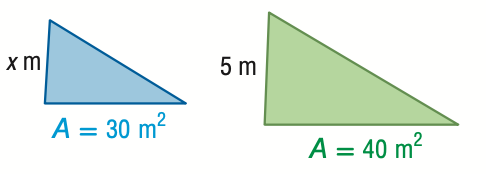Answer the mathemtical geometry problem and directly provide the correct option letter.
Question: For the pair of similar figures, use the given areas to find the scale factor from the blue to the green figure.
Choices: A: \frac { 3 } { 4 } B: \frac { \sqrt { 3 } } { 2 } C: \frac { 2 } { \sqrt { 3 } } D: \frac { 4 } { 3 } B 